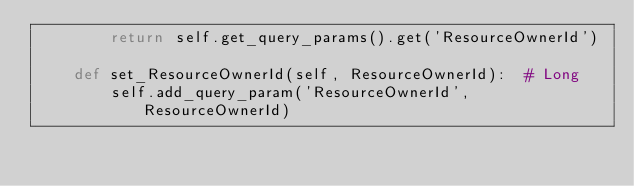Convert code to text. <code><loc_0><loc_0><loc_500><loc_500><_Python_>		return self.get_query_params().get('ResourceOwnerId')

	def set_ResourceOwnerId(self, ResourceOwnerId):  # Long
		self.add_query_param('ResourceOwnerId', ResourceOwnerId)</code> 